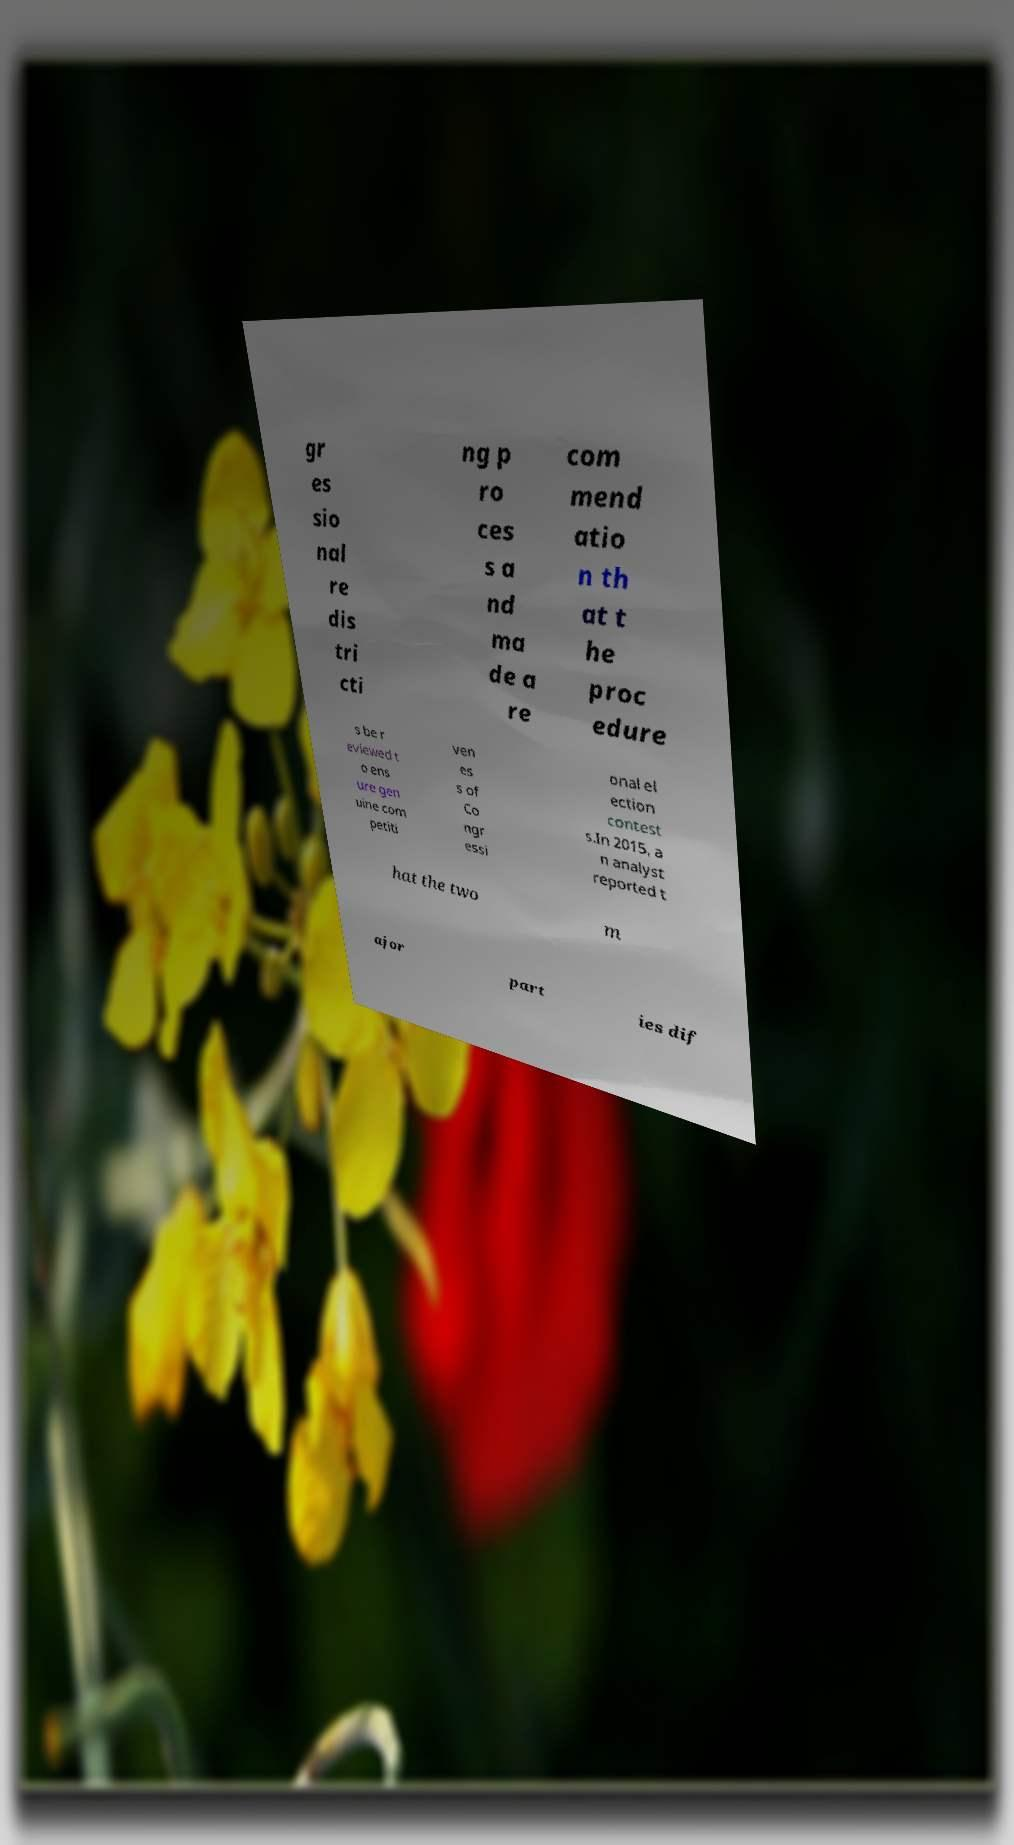Please identify and transcribe the text found in this image. gr es sio nal re dis tri cti ng p ro ces s a nd ma de a re com mend atio n th at t he proc edure s be r eviewed t o ens ure gen uine com petiti ven es s of Co ngr essi onal el ection contest s.In 2015, a n analyst reported t hat the two m ajor part ies dif 